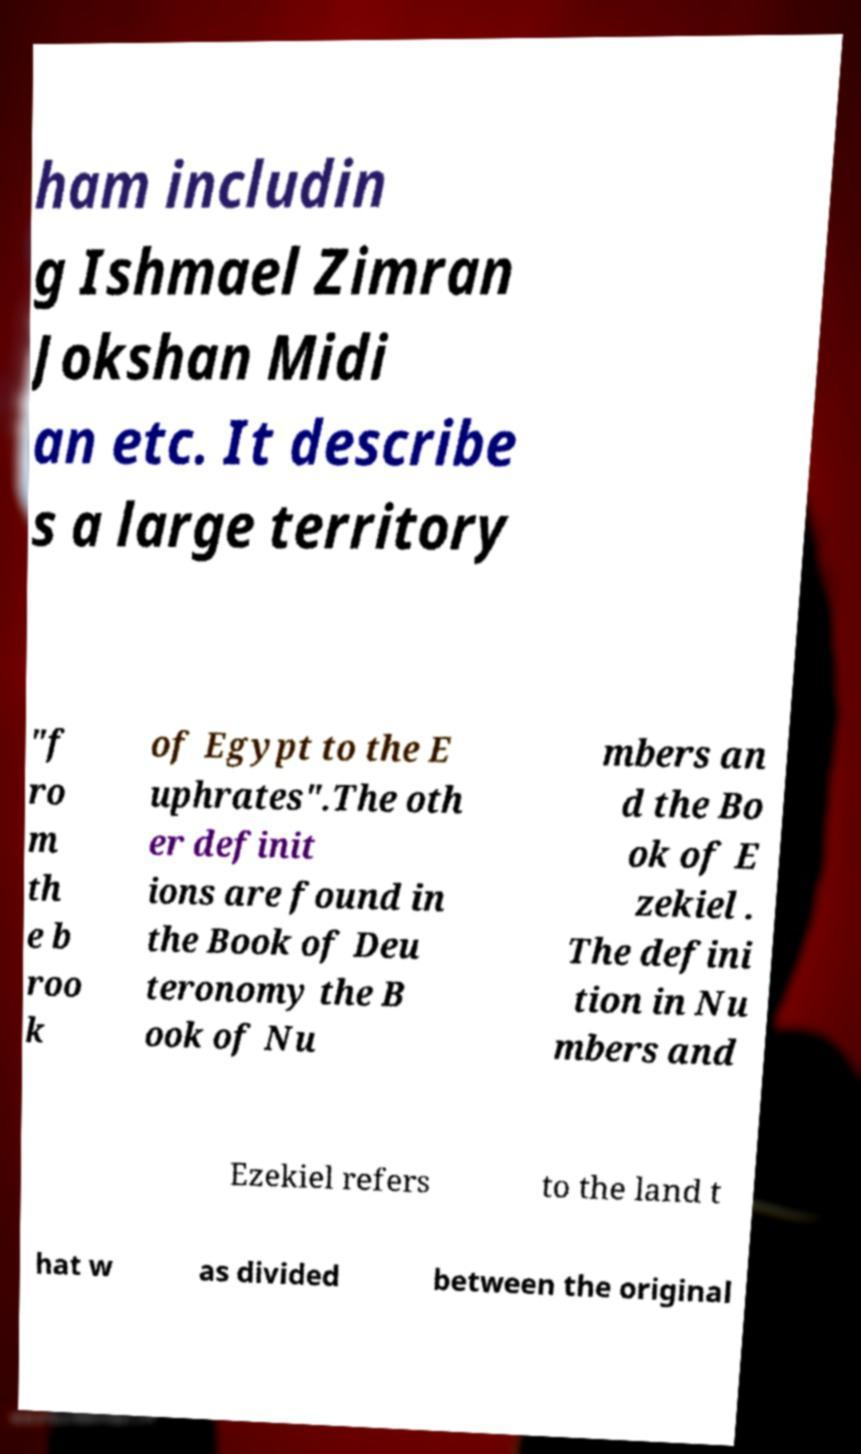Could you assist in decoding the text presented in this image and type it out clearly? ham includin g Ishmael Zimran Jokshan Midi an etc. It describe s a large territory "f ro m th e b roo k of Egypt to the E uphrates".The oth er definit ions are found in the Book of Deu teronomy the B ook of Nu mbers an d the Bo ok of E zekiel . The defini tion in Nu mbers and Ezekiel refers to the land t hat w as divided between the original 